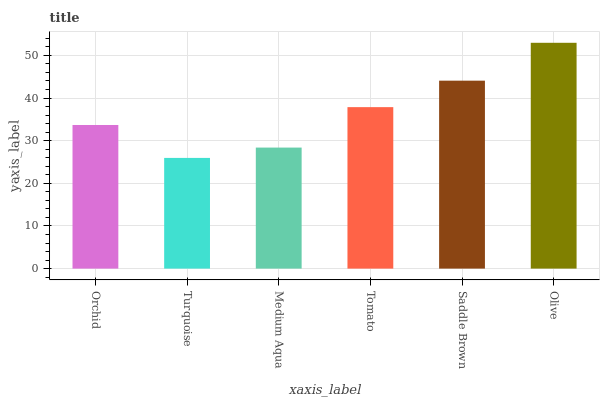Is Turquoise the minimum?
Answer yes or no. Yes. Is Olive the maximum?
Answer yes or no. Yes. Is Medium Aqua the minimum?
Answer yes or no. No. Is Medium Aqua the maximum?
Answer yes or no. No. Is Medium Aqua greater than Turquoise?
Answer yes or no. Yes. Is Turquoise less than Medium Aqua?
Answer yes or no. Yes. Is Turquoise greater than Medium Aqua?
Answer yes or no. No. Is Medium Aqua less than Turquoise?
Answer yes or no. No. Is Tomato the high median?
Answer yes or no. Yes. Is Orchid the low median?
Answer yes or no. Yes. Is Medium Aqua the high median?
Answer yes or no. No. Is Saddle Brown the low median?
Answer yes or no. No. 